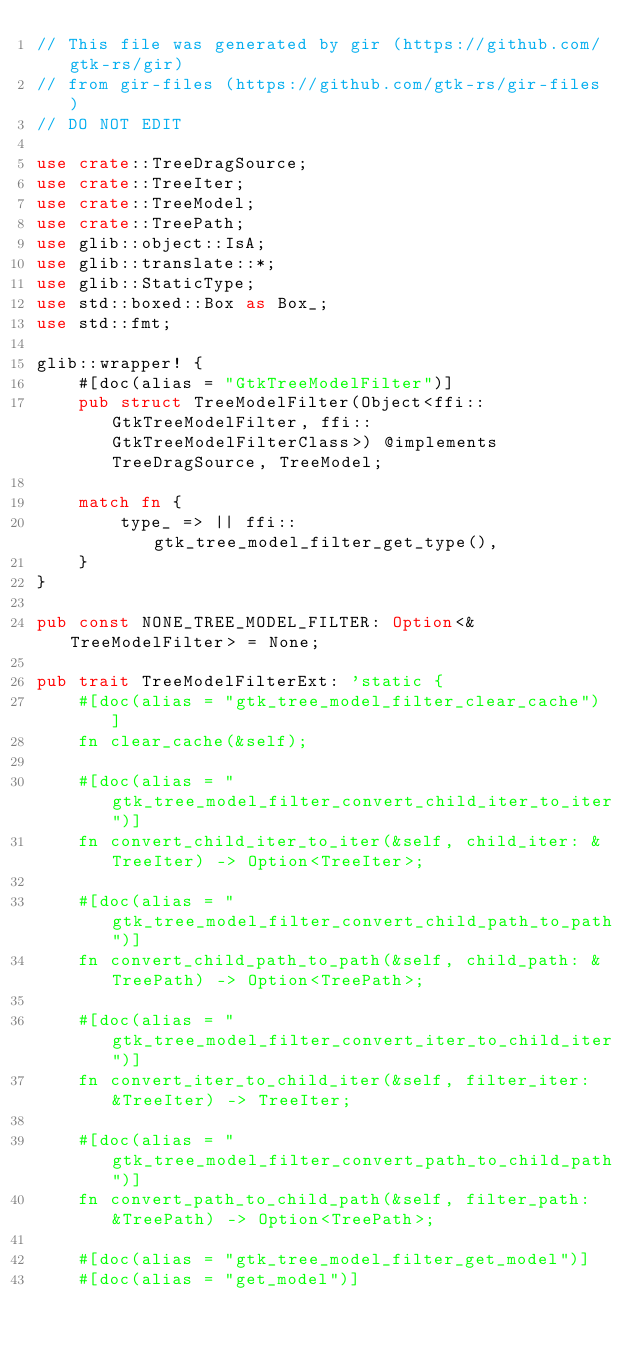Convert code to text. <code><loc_0><loc_0><loc_500><loc_500><_Rust_>// This file was generated by gir (https://github.com/gtk-rs/gir)
// from gir-files (https://github.com/gtk-rs/gir-files)
// DO NOT EDIT

use crate::TreeDragSource;
use crate::TreeIter;
use crate::TreeModel;
use crate::TreePath;
use glib::object::IsA;
use glib::translate::*;
use glib::StaticType;
use std::boxed::Box as Box_;
use std::fmt;

glib::wrapper! {
    #[doc(alias = "GtkTreeModelFilter")]
    pub struct TreeModelFilter(Object<ffi::GtkTreeModelFilter, ffi::GtkTreeModelFilterClass>) @implements TreeDragSource, TreeModel;

    match fn {
        type_ => || ffi::gtk_tree_model_filter_get_type(),
    }
}

pub const NONE_TREE_MODEL_FILTER: Option<&TreeModelFilter> = None;

pub trait TreeModelFilterExt: 'static {
    #[doc(alias = "gtk_tree_model_filter_clear_cache")]
    fn clear_cache(&self);

    #[doc(alias = "gtk_tree_model_filter_convert_child_iter_to_iter")]
    fn convert_child_iter_to_iter(&self, child_iter: &TreeIter) -> Option<TreeIter>;

    #[doc(alias = "gtk_tree_model_filter_convert_child_path_to_path")]
    fn convert_child_path_to_path(&self, child_path: &TreePath) -> Option<TreePath>;

    #[doc(alias = "gtk_tree_model_filter_convert_iter_to_child_iter")]
    fn convert_iter_to_child_iter(&self, filter_iter: &TreeIter) -> TreeIter;

    #[doc(alias = "gtk_tree_model_filter_convert_path_to_child_path")]
    fn convert_path_to_child_path(&self, filter_path: &TreePath) -> Option<TreePath>;

    #[doc(alias = "gtk_tree_model_filter_get_model")]
    #[doc(alias = "get_model")]</code> 